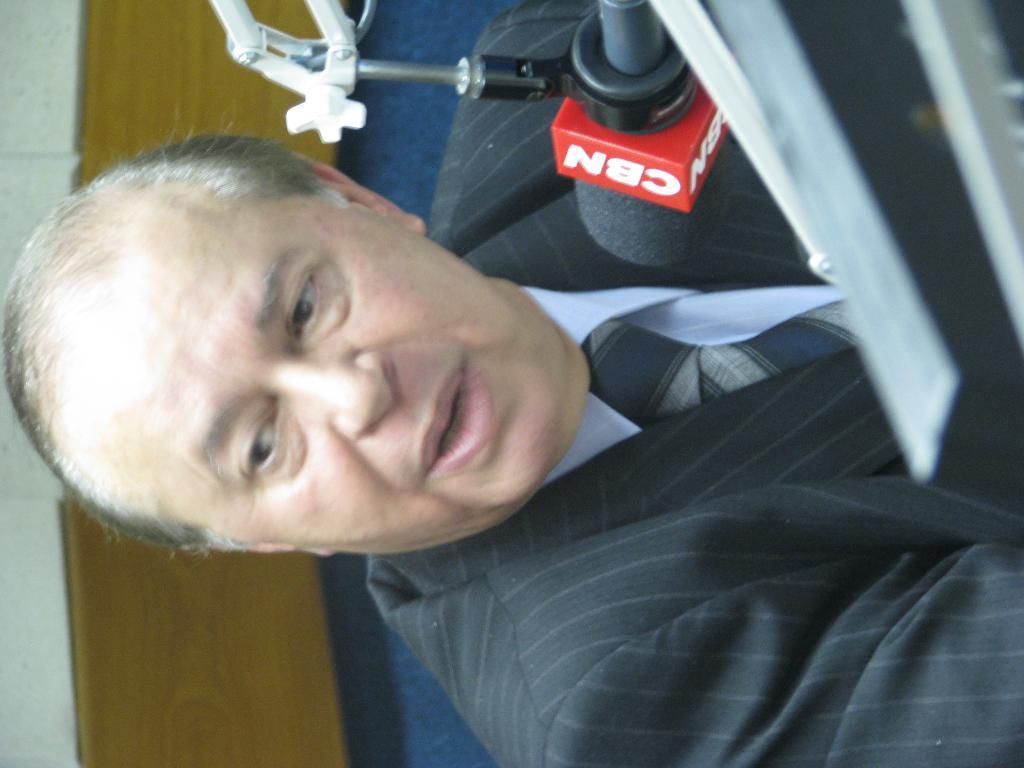Can you describe this image briefly? In this image we can see a person, in front of him there is a mic with text on it, also we can see the wall. 